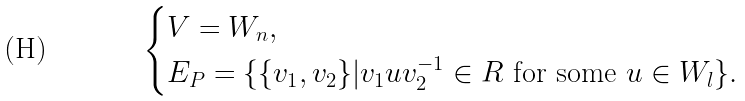<formula> <loc_0><loc_0><loc_500><loc_500>\begin{cases} V = W _ { n } , \\ E _ { P } = \{ \{ v _ { 1 } , v _ { 2 } \} | v _ { 1 } u v _ { 2 } ^ { - 1 } \in R \text { for some } u \in W _ { l } \} . \end{cases}</formula> 